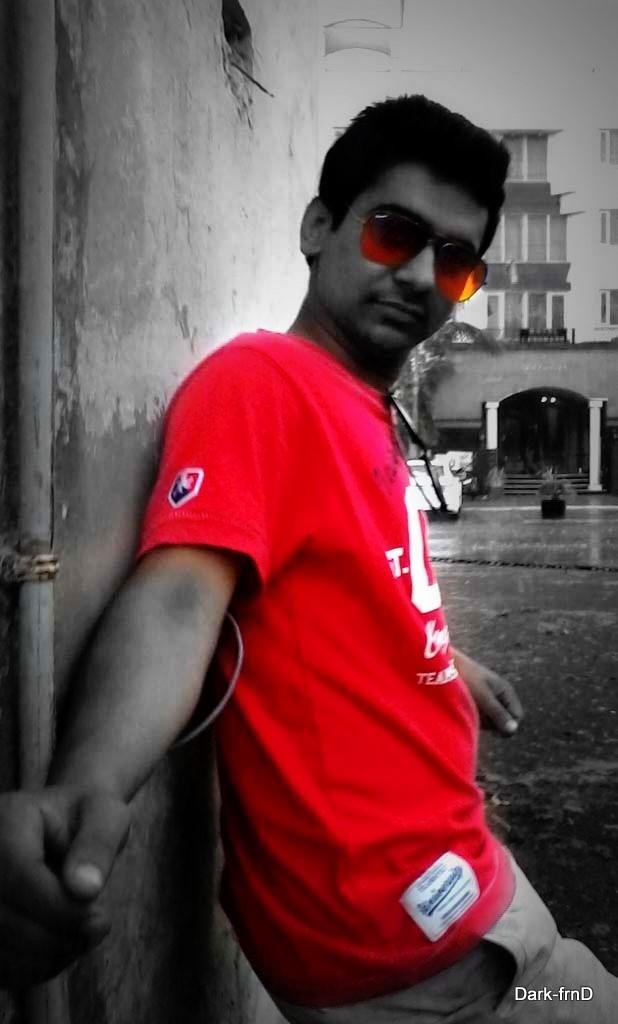What is the main subject of the image? The main subject of the image is a man. What is the man wearing on his upper body? The man is wearing a red T-shirt. What type of eyewear is the man wearing? The man is wearing shades. What is the man's posture in the image? The man is standing. What can be seen on the left side of the image? There is a wall on the left side of the image. What is visible in the background of the image? There is a building and a car in the background of the image. Is the man wearing a mask in the image? No, the man is not wearing a mask in the image; he is wearing shades. What type of railway is visible in the image? There is no railway present in the image. 